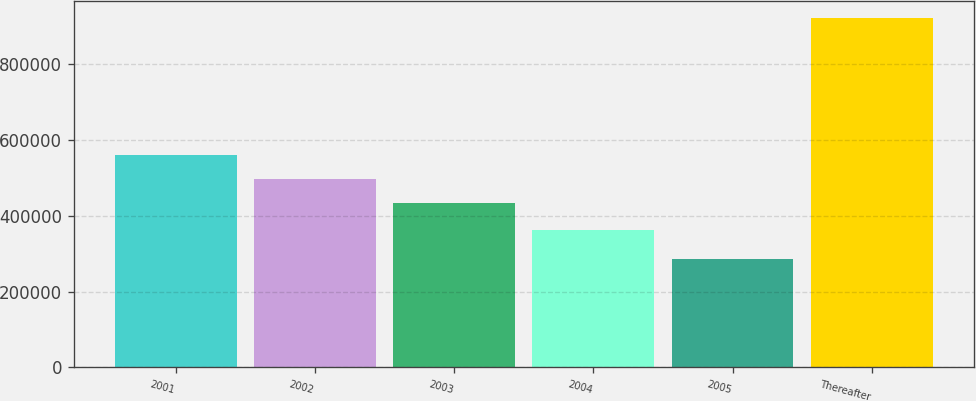Convert chart. <chart><loc_0><loc_0><loc_500><loc_500><bar_chart><fcel>2001<fcel>2002<fcel>2003<fcel>2004<fcel>2005<fcel>Thereafter<nl><fcel>561812<fcel>498340<fcel>434868<fcel>363205<fcel>286733<fcel>921455<nl></chart> 